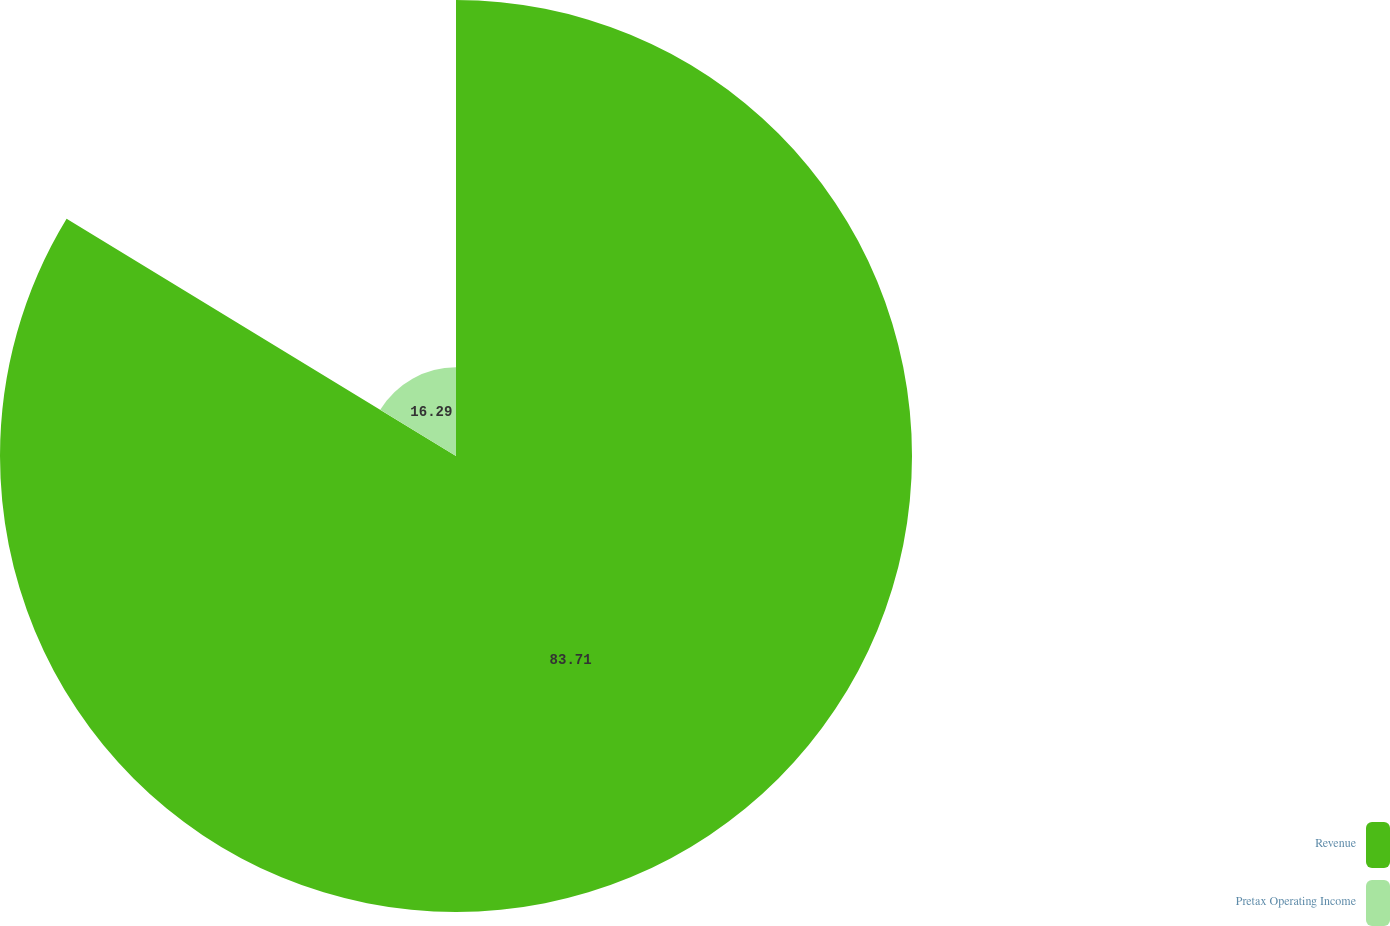Convert chart to OTSL. <chart><loc_0><loc_0><loc_500><loc_500><pie_chart><fcel>Revenue<fcel>Pretax Operating Income<nl><fcel>83.71%<fcel>16.29%<nl></chart> 